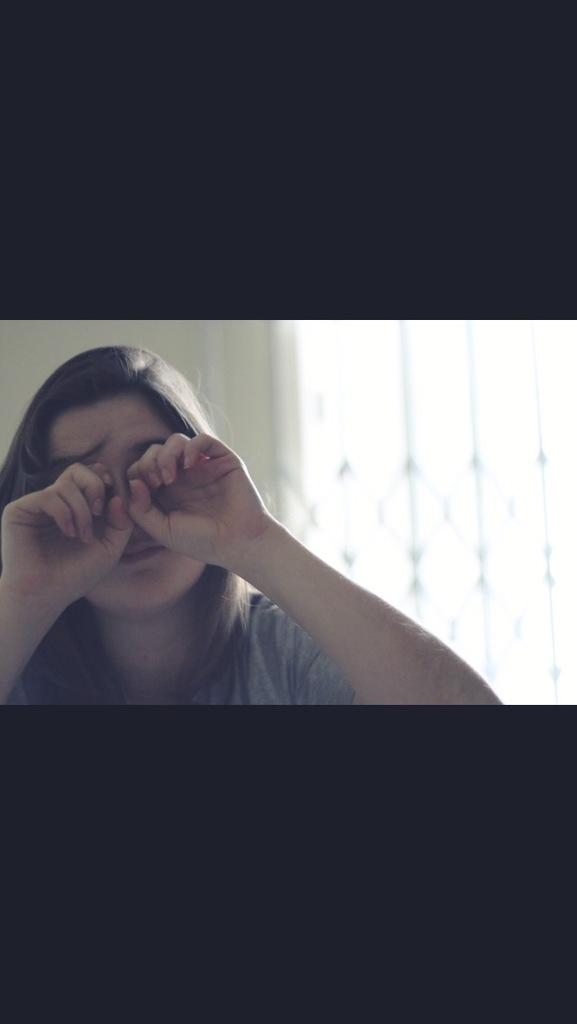Who is present in the image? There is a woman in the image. What is the woman doing in the image? The woman is rubbing her eyes. What can be observed about the image's borders? There is a black border at the top and bottom of the image. What type of crown is the woman wearing in the image? There is no crown present in the image; the woman is rubbing her eyes. What brand of toothpaste is visible in the image? There is no toothpaste present in the image. 